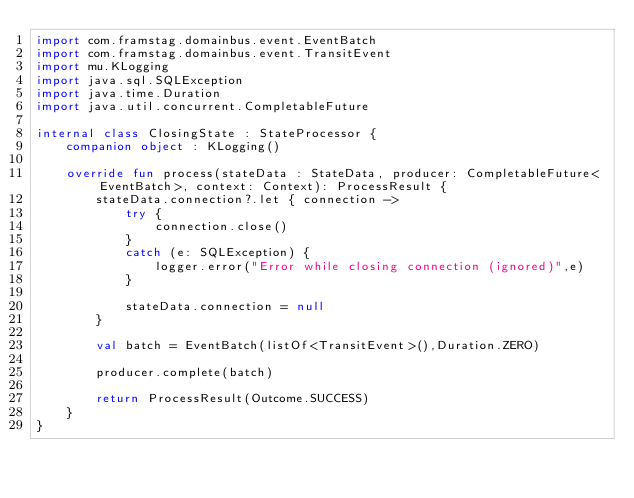<code> <loc_0><loc_0><loc_500><loc_500><_Kotlin_>import com.framstag.domainbus.event.EventBatch
import com.framstag.domainbus.event.TransitEvent
import mu.KLogging
import java.sql.SQLException
import java.time.Duration
import java.util.concurrent.CompletableFuture

internal class ClosingState : StateProcessor {
    companion object : KLogging()

    override fun process(stateData : StateData, producer: CompletableFuture<EventBatch>, context: Context): ProcessResult {
        stateData.connection?.let { connection ->
            try {
                connection.close()
            }
            catch (e: SQLException) {
                logger.error("Error while closing connection (ignored)",e)
            }

            stateData.connection = null
        }

        val batch = EventBatch(listOf<TransitEvent>(),Duration.ZERO)

        producer.complete(batch)

        return ProcessResult(Outcome.SUCCESS)
    }
}</code> 